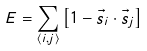<formula> <loc_0><loc_0><loc_500><loc_500>E = \sum _ { \langle i , j \rangle } \left [ 1 - \vec { s } _ { i } \cdot \vec { s } _ { j } \right ]</formula> 